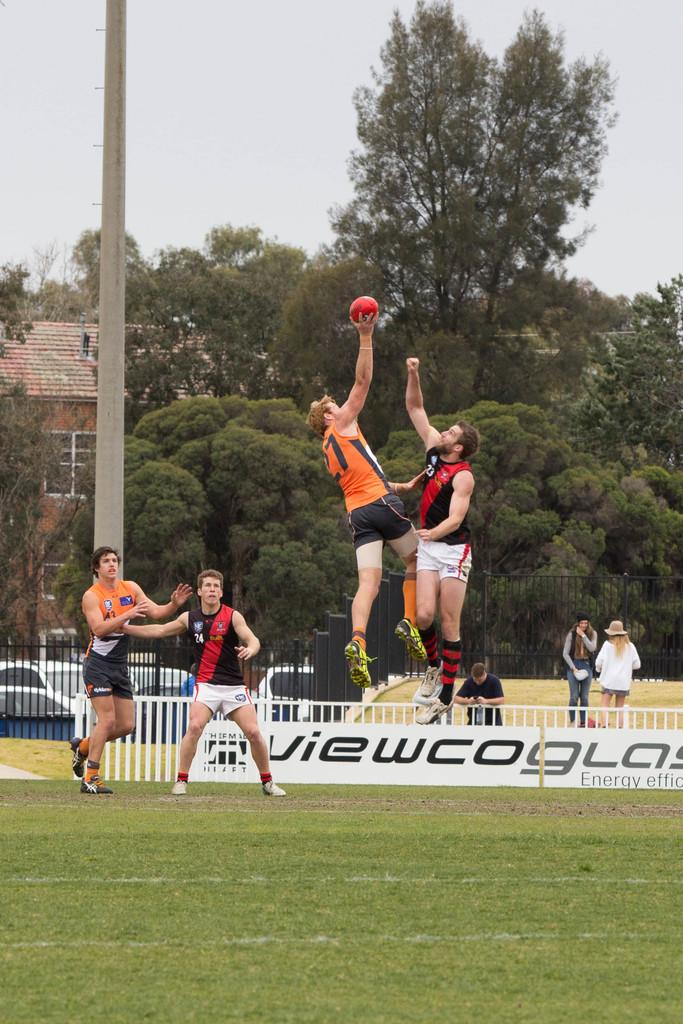Provide a one-sentence caption for the provided image. Four men playing a ball sport, on a field sponsored by viewco glass. 